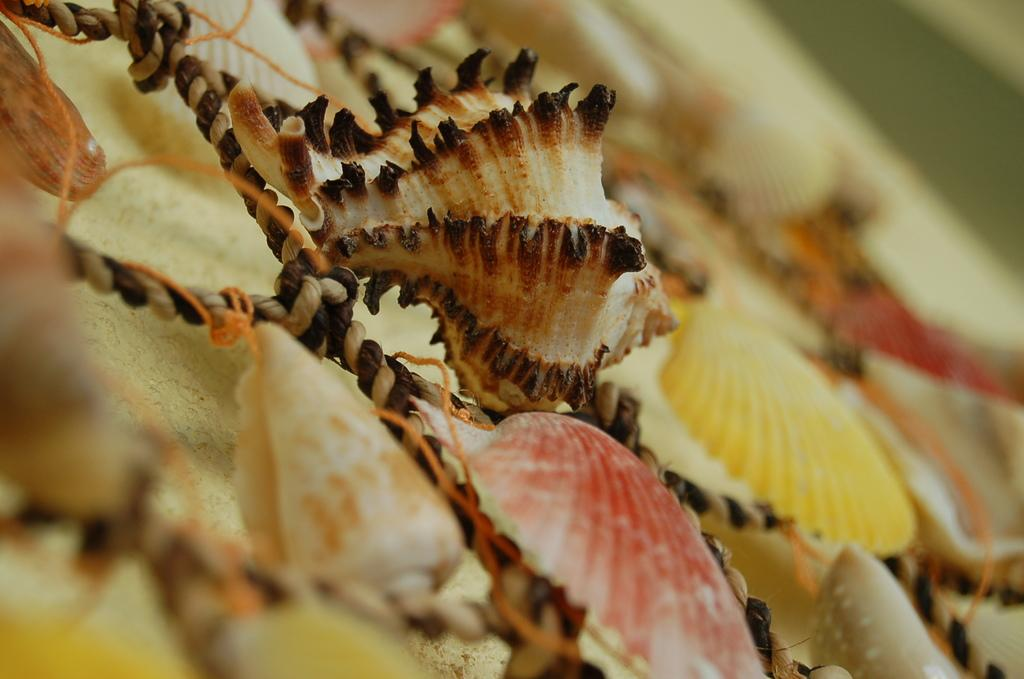What type of objects can be seen in the image? There are seashells and ropes in the image. Can you describe the seashells in the image? The seashells are likely natural objects found near the ocean or a beach. What might the ropes be used for in the image? The ropes could be used for various purposes, such as tying or securing objects. Are there any plantations visible in the image? There is no mention of a plantation in the provided facts, and therefore no such feature can be observed in the image. How many legs can be seen on the seashells in the image? Seashells do not have legs; they are the hard, protective outer layer of marine mollusks. 